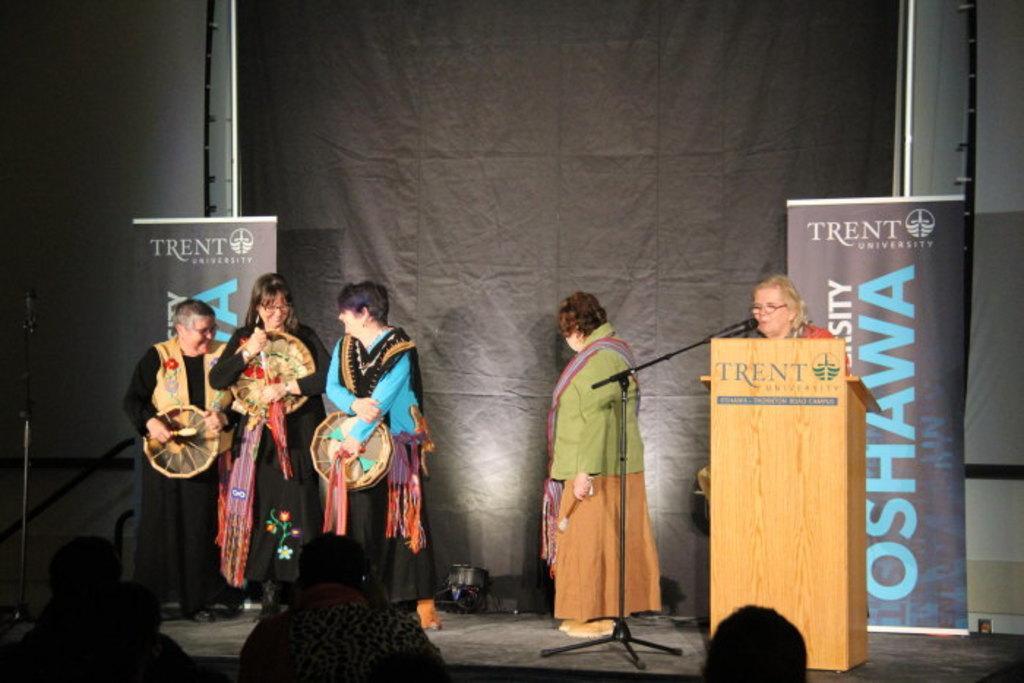Can you describe this image briefly? In this picture we can see a group of people where some are standing on stage and a woman standing at podium and talking on mic and in the background we can see a banner. 